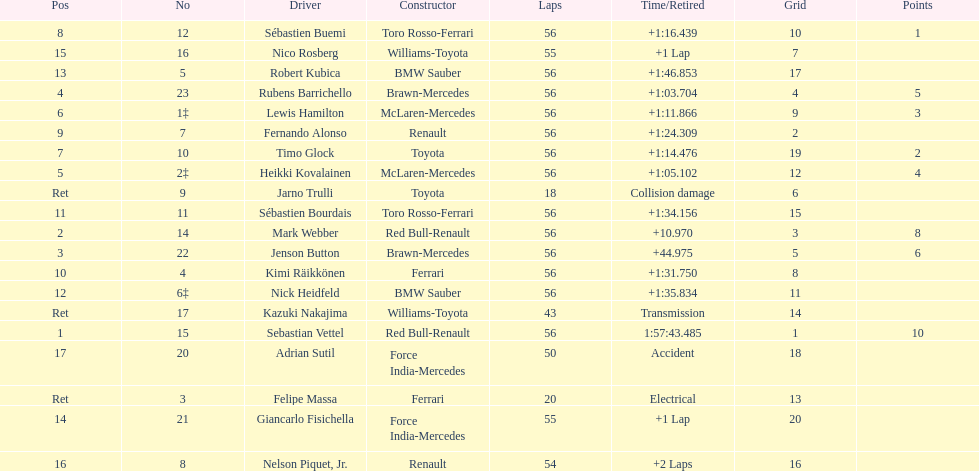Heikki kovalainen and lewis hamilton both had which constructor? McLaren-Mercedes. 